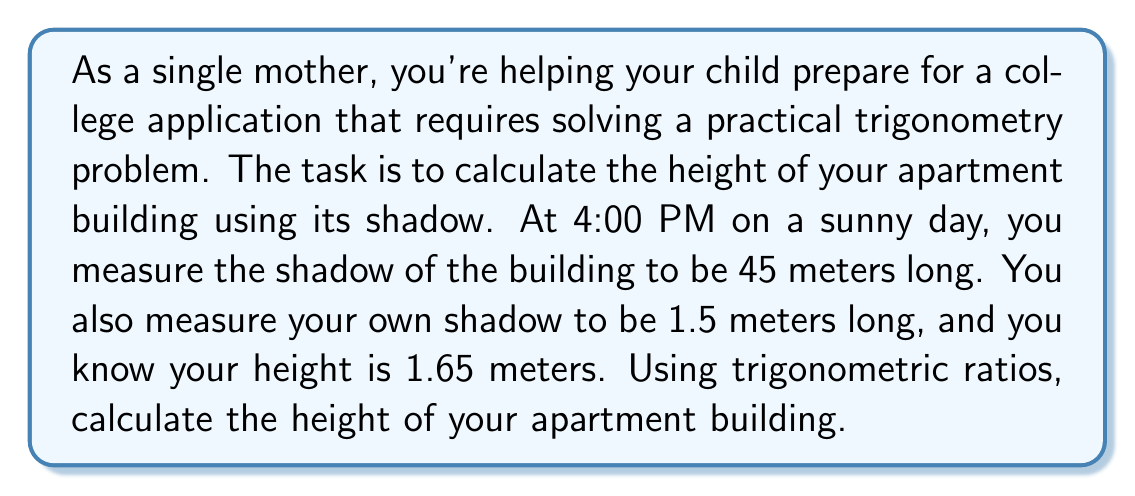Give your solution to this math problem. Let's approach this step-by-step:

1) First, we need to understand that the angle of elevation of the sun is the same for both you and the building. This means the triangles formed by you and your shadow, and the building and its shadow, are similar triangles.

2) Let's define some variables:
   $h$ = height of the building (what we're solving for)
   $s$ = length of the building's shadow = 45 meters
   $H$ = your height = 1.65 meters
   $S$ = length of your shadow = 1.5 meters

3) We can set up a proportion based on the similar triangles:

   $$\frac{h}{s} = \frac{H}{S}$$

4) Substituting the known values:

   $$\frac{h}{45} = \frac{1.65}{1.5}$$

5) Cross multiply:

   $$1.5h = 45 \cdot 1.65$$

6) Simplify the right side:

   $$1.5h = 74.25$$

7) Divide both sides by 1.5:

   $$h = \frac{74.25}{1.5} = 49.5$$

Therefore, the height of the building is 49.5 meters.

Note: This method uses the concept of similar triangles, which is based on the trigonometric principle that the ratio of sides in similar right triangles is constant, regardless of the size of the triangle.
Answer: The height of the apartment building is 49.5 meters. 